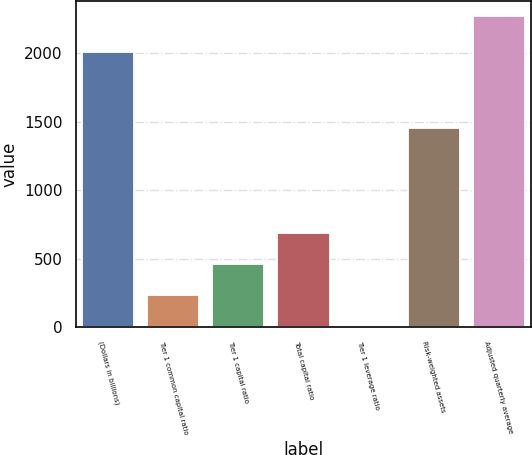<chart> <loc_0><loc_0><loc_500><loc_500><bar_chart><fcel>(Dollars in billions)<fcel>Tier 1 common capital ratio<fcel>Tier 1 capital ratio<fcel>Total capital ratio<fcel>Tier 1 leverage ratio<fcel>Risk-weighted assets<fcel>Adjusted quarterly average<nl><fcel>2010<fcel>233.49<fcel>459.77<fcel>686.05<fcel>7.21<fcel>1456<fcel>2270<nl></chart> 